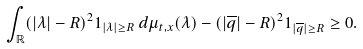Convert formula to latex. <formula><loc_0><loc_0><loc_500><loc_500>\int _ { \mathbb { R } } ( | \lambda | - R ) ^ { 2 } { 1 } _ { | \lambda | \geq R } \, d \mu _ { t , x } ( \lambda ) - ( | \overline { q } | - R ) ^ { 2 } { 1 } _ { | \overline { q } | \geq R } \geq 0 .</formula> 